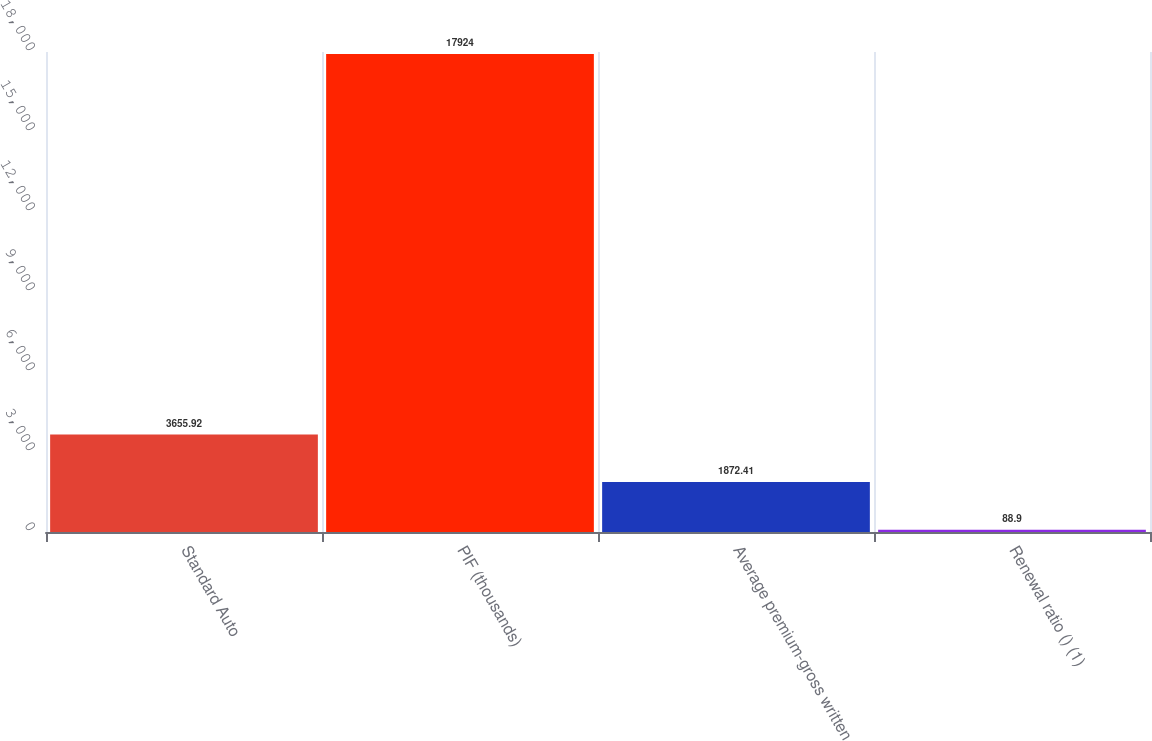Convert chart to OTSL. <chart><loc_0><loc_0><loc_500><loc_500><bar_chart><fcel>Standard Auto<fcel>PIF (thousands)<fcel>Average premium-gross written<fcel>Renewal ratio () (1)<nl><fcel>3655.92<fcel>17924<fcel>1872.41<fcel>88.9<nl></chart> 